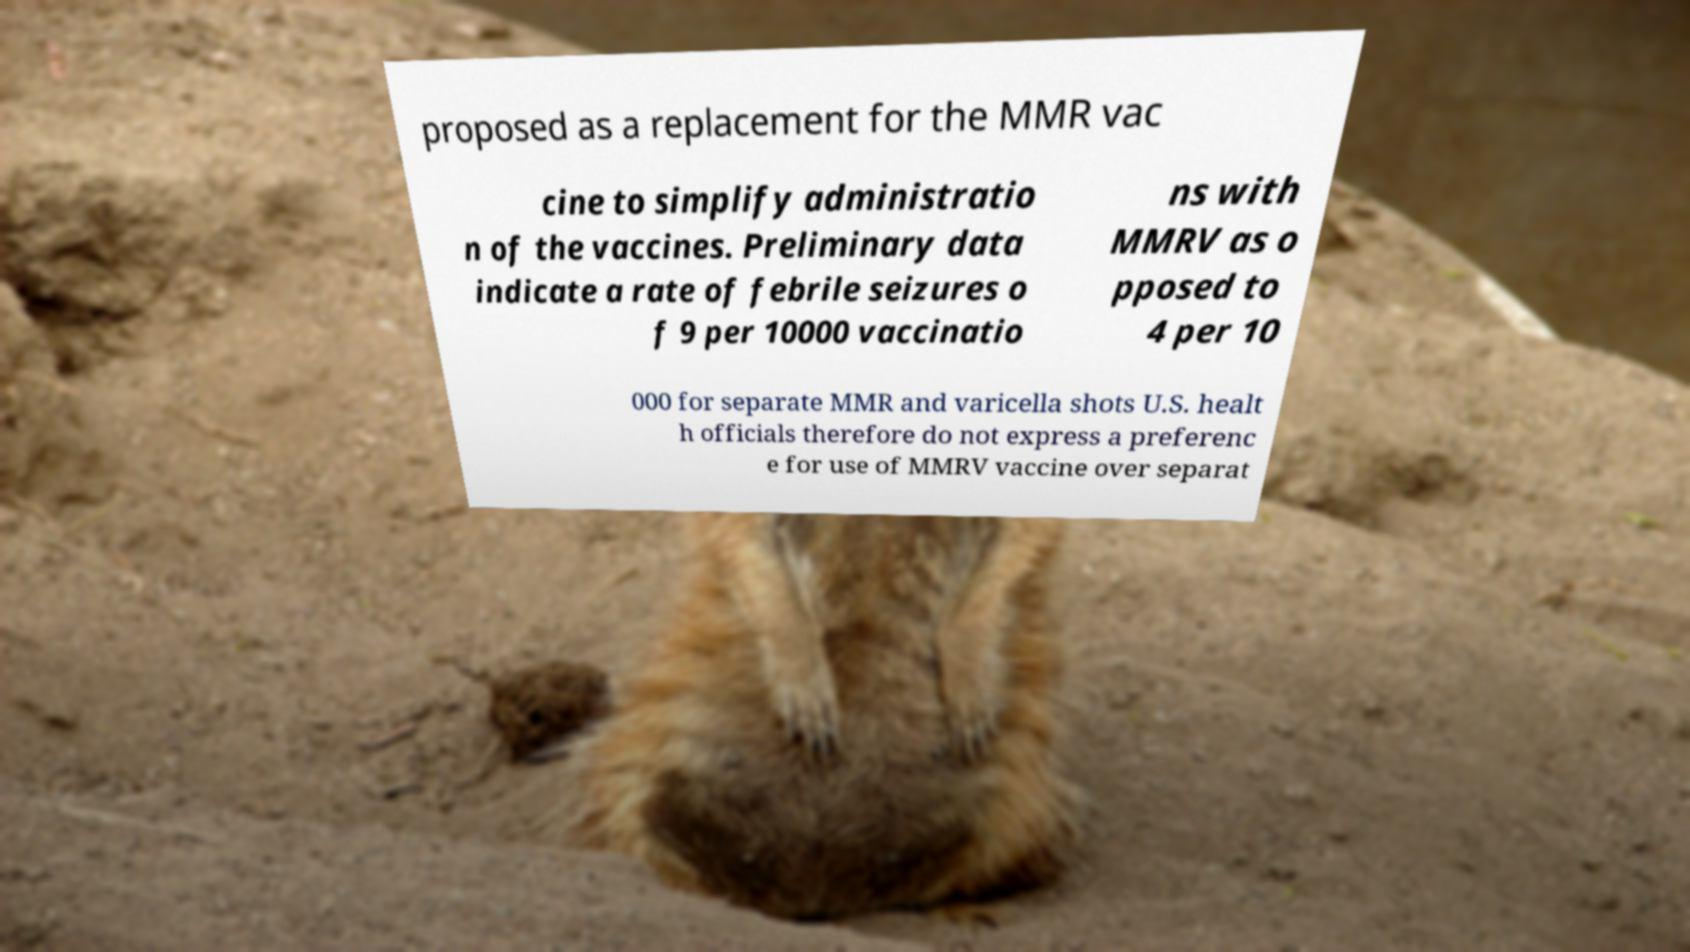I need the written content from this picture converted into text. Can you do that? proposed as a replacement for the MMR vac cine to simplify administratio n of the vaccines. Preliminary data indicate a rate of febrile seizures o f 9 per 10000 vaccinatio ns with MMRV as o pposed to 4 per 10 000 for separate MMR and varicella shots U.S. healt h officials therefore do not express a preferenc e for use of MMRV vaccine over separat 